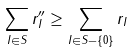Convert formula to latex. <formula><loc_0><loc_0><loc_500><loc_500>\sum _ { I \in S } r _ { I } ^ { \prime \prime } \geq \sum _ { I \in S - \{ 0 \} } r _ { I }</formula> 